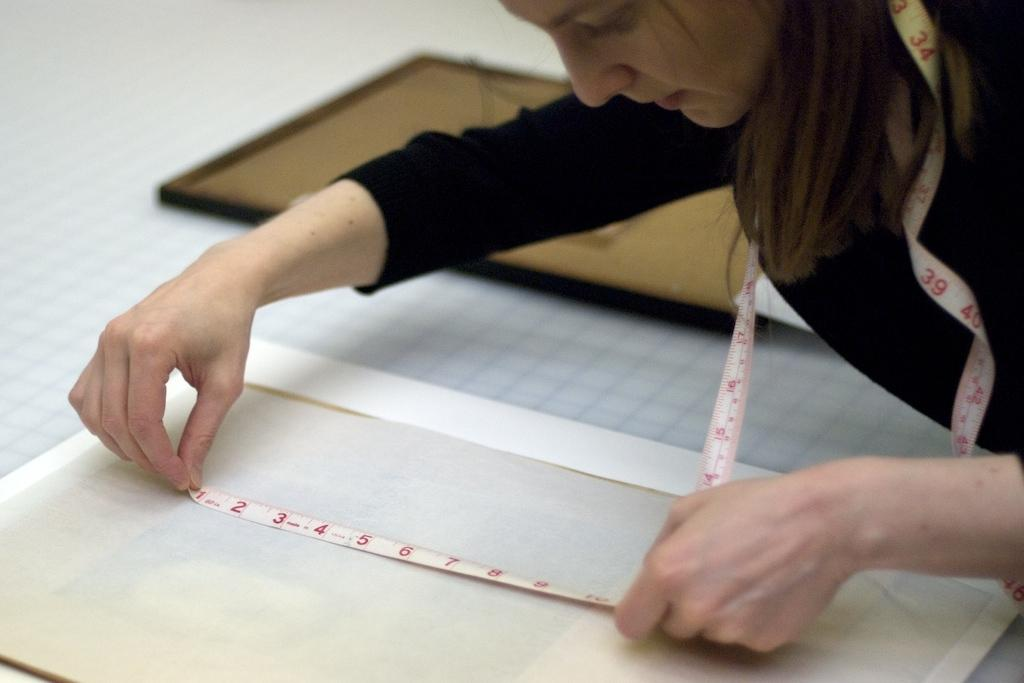Who is the main subject in the image? There is a woman in the image. What is the woman holding in the image? The woman is holding a tape measure. What can be seen in front of the woman? There are objects in front of the woman. What type of insect can be seen crawling on the woman's shoulder in the image? There is no insect present on the woman's shoulder in the image. How does the woman's expression show anger in the image? The woman's expression does not show anger in the image; there is no indication of her emotional state. 